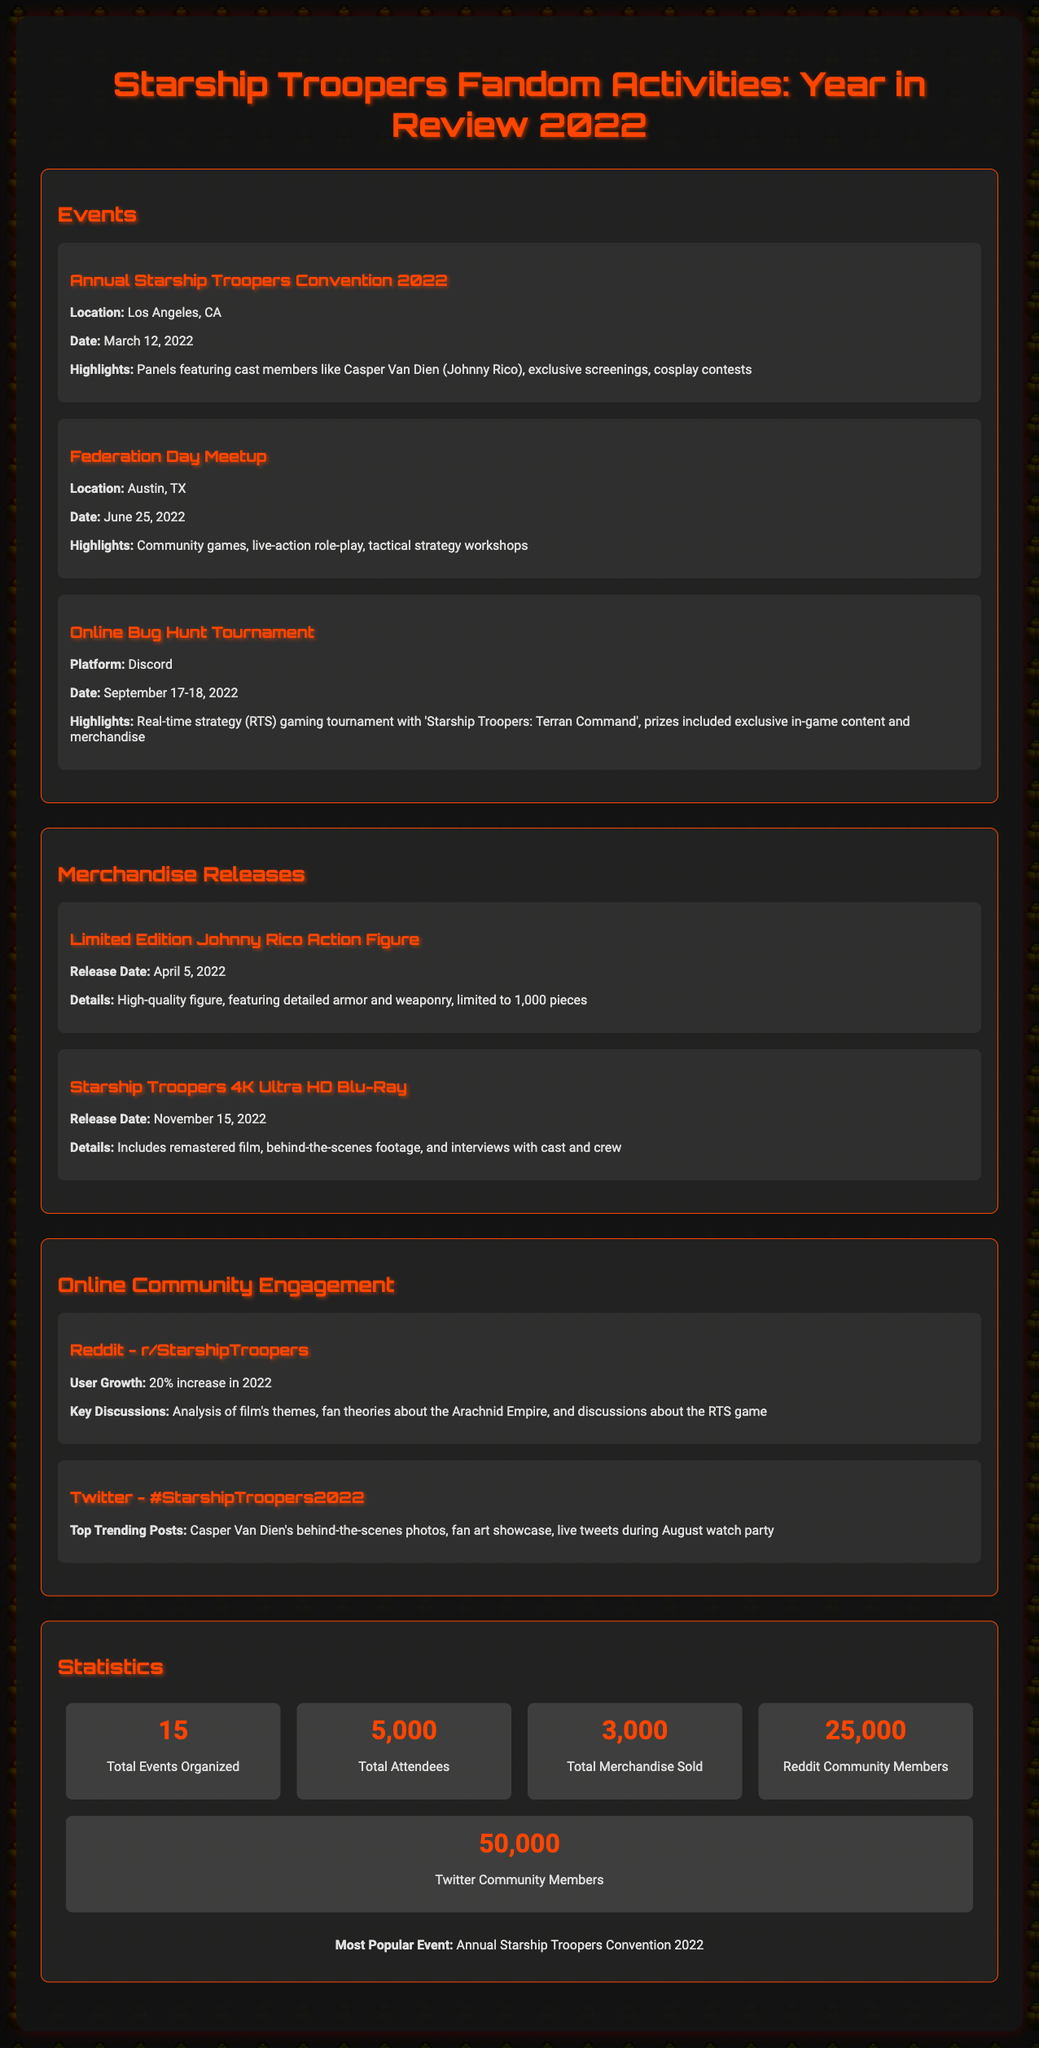What was the location of the Annual Starship Troopers Convention 2022? The document specifies that the Annual Starship Troopers Convention 2022 took place in Los Angeles, CA.
Answer: Los Angeles, CA What date was the Federation Day Meetup held? According to the document, the Federation Day Meetup occurred on June 25, 2022.
Answer: June 25, 2022 How many total merchandise items were sold in 2022? The document states that a total of 3,000 merchandise items were sold during the year.
Answer: 3,000 What percentage increase in Reddit user growth was reported in 2022? The document indicates a 20% increase in Reddit user growth for the year 2022.
Answer: 20% What is the total number of events organized in 2022? The document lists 15 as the total number of events that were organized in 2022.
Answer: 15 What was the release date of the Limited Edition Johnny Rico Action Figure? The document reveals the release date of the Limited Edition Johnny Rico Action Figure as April 5, 2022.
Answer: April 5, 2022 Which was the most popular event according to the document? The document identifies the Annual Starship Troopers Convention 2022 as the most popular event.
Answer: Annual Starship Troopers Convention 2022 What platform hosted the Online Bug Hunt Tournament? The document states that the Online Bug Hunt Tournament was hosted on Discord.
Answer: Discord How many total attendees were recorded for the events in 2022? The document provides the total number of attendees as 5,000.
Answer: 5,000 